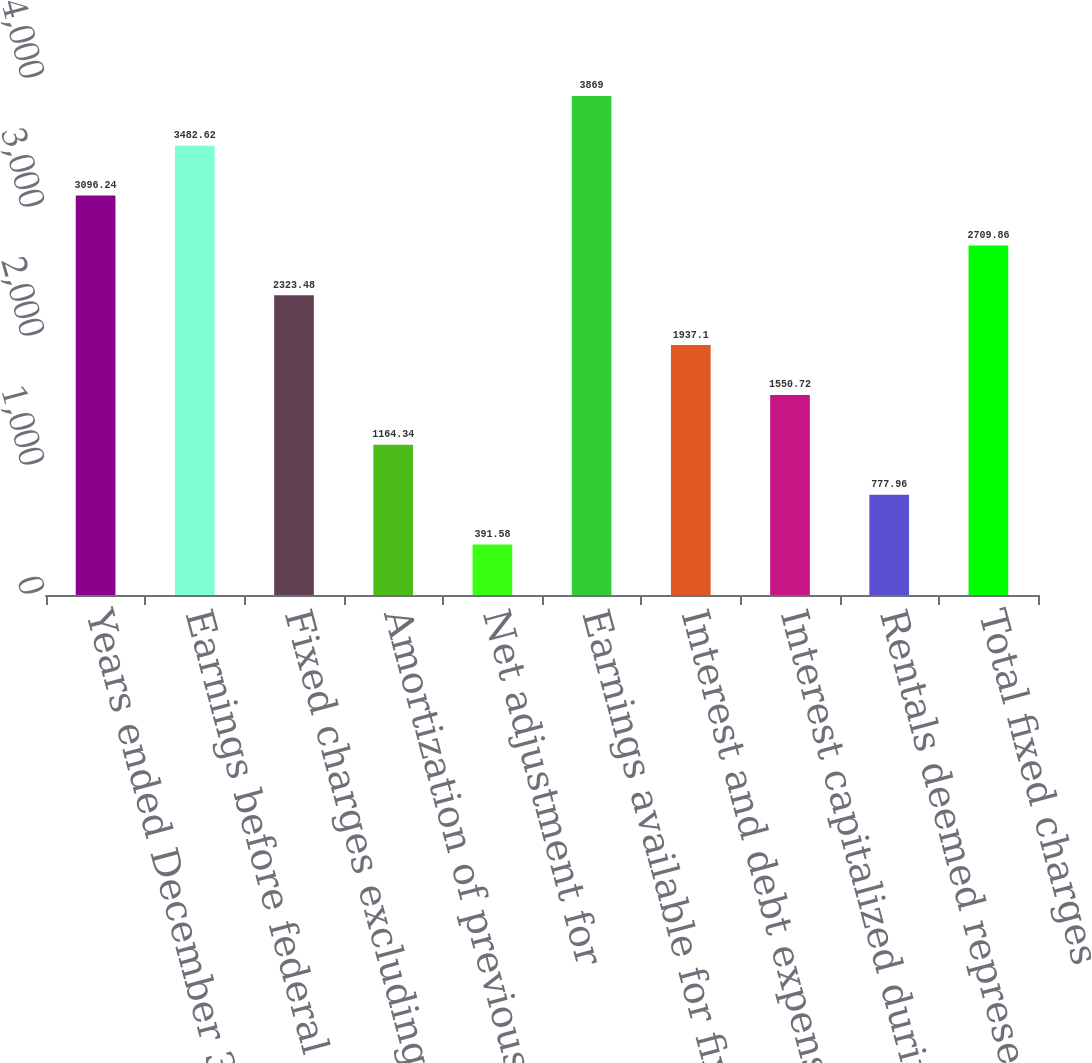<chart> <loc_0><loc_0><loc_500><loc_500><bar_chart><fcel>Years ended December 31<fcel>Earnings before federal taxes<fcel>Fixed charges excluding<fcel>Amortization of previously<fcel>Net adjustment for<fcel>Earnings available for fixed<fcel>Interest and debt expense (1)<fcel>Interest capitalized during<fcel>Rentals deemed representative<fcel>Total fixed charges<nl><fcel>3096.24<fcel>3482.62<fcel>2323.48<fcel>1164.34<fcel>391.58<fcel>3869<fcel>1937.1<fcel>1550.72<fcel>777.96<fcel>2709.86<nl></chart> 